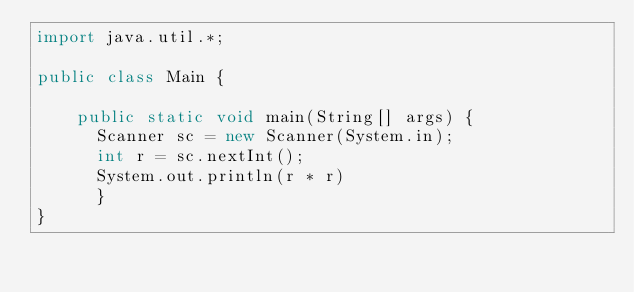Convert code to text. <code><loc_0><loc_0><loc_500><loc_500><_Java_>import java.util.*;

public class Main {
    
    public static void main(String[] args) {
      Scanner sc = new Scanner(System.in);
      int r = sc.nextInt();
      System.out.println(r * r)
      }
}</code> 